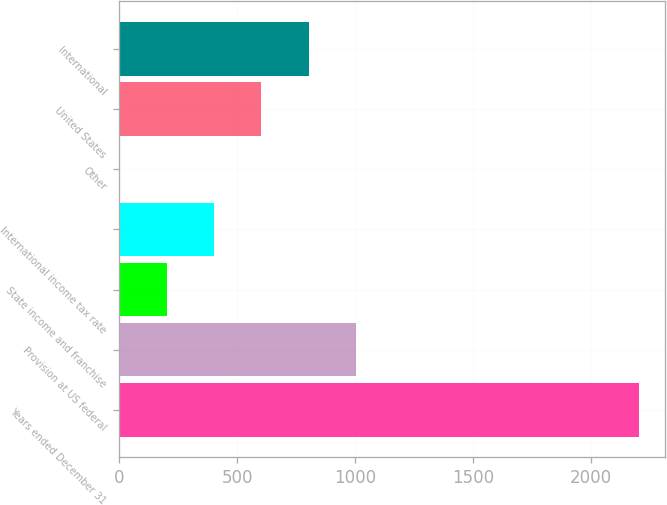<chart> <loc_0><loc_0><loc_500><loc_500><bar_chart><fcel>Years ended December 31<fcel>Provision at US federal<fcel>State income and franchise<fcel>International income tax rate<fcel>Other<fcel>United States<fcel>International<nl><fcel>2204.36<fcel>1002.2<fcel>200.76<fcel>401.12<fcel>0.4<fcel>601.48<fcel>801.84<nl></chart> 